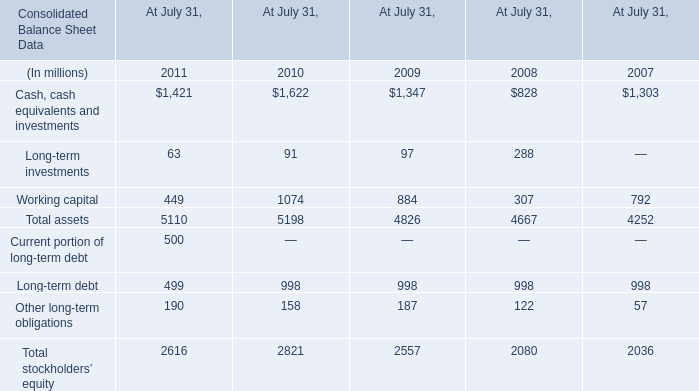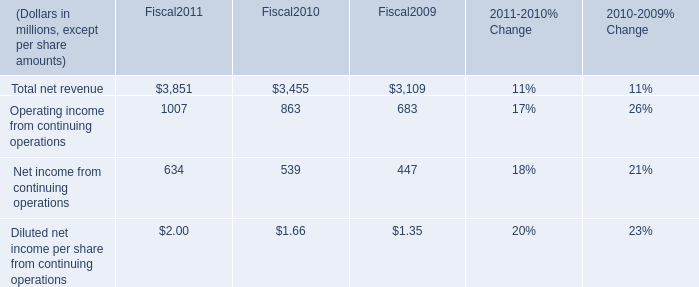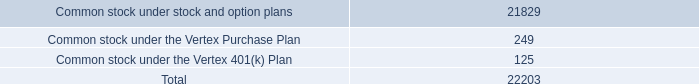What is the total amount of Cash, cash equivalents and investments of At July 31, 2009, and Operating income from continuing operations of Fiscal2011 ? 
Computations: (1347.0 + 1007.0)
Answer: 2354.0. 